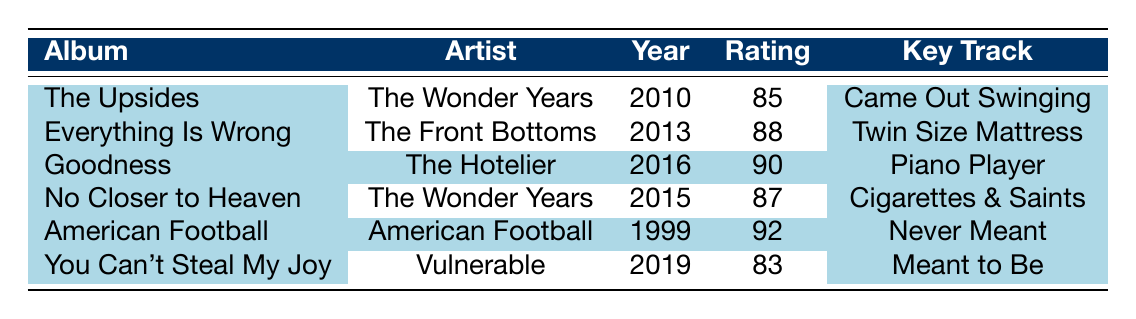What is the highest critical rating among the albums listed? The critical ratings of the albums are 85, 88, 90, 87, 92, and 83. The highest value is 92, which corresponds to the album "American Football" by the band of the same name.
Answer: 92 Which album by The Wonder Years was released in 2015? From the table, we see that "No Closer to Heaven" is listed as the album by The Wonder Years with a release year of 2015.
Answer: No Closer to Heaven How many albums have a critical rating above 85? The albums with ratings above 85 are: "Everything Is Wrong" 88, "Goodness" 90, "No Closer to Heaven" 87, and "American Football" 92. This gives us a total of four albums with ratings greater than 85.
Answer: 4 Is "You Can't Steal My Joy" rated higher than 85? The critical rating for "You Can't Steal My Joy" is 83. Since 83 is less than 85, this statement is false.
Answer: No What is the average critical rating of albums by The Wonder Years? The critical ratings for The Wonder Years albums are 85 and 87. To find the average: (85 + 87) / 2 = 171 / 2 = 85.5. Therefore, the average rating of their albums is 85.5.
Answer: 85.5 Which album has "Came Out Swinging" as a key track, and what is its rating? The key track "Came Out Swinging" is from "The Upsides" by The Wonder Years, which has a critical rating of 85.
Answer: The Upsides, 85 Was "Goodness" released before "You Can't Steal My Joy"? "Goodness" was released in 2016 and "You Can't Steal My Joy" in 2019. Since 2016 is earlier than 2019, this statement is true.
Answer: Yes How many albums have been released in the 2010s? The albums released in the 2010s are "The Upsides" (2010), "Everything Is Wrong" (2013), "No Closer to Heaven" (2015), and "You Can't Steal My Joy" (2019). This totals four albums released in that decade.
Answer: 4 Which artist has the highest-rated album based on the table? The artist with the highest-rated album, "American Football," has a critical rating of 92. This makes their album the highest-rated in the table.
Answer: American Football 